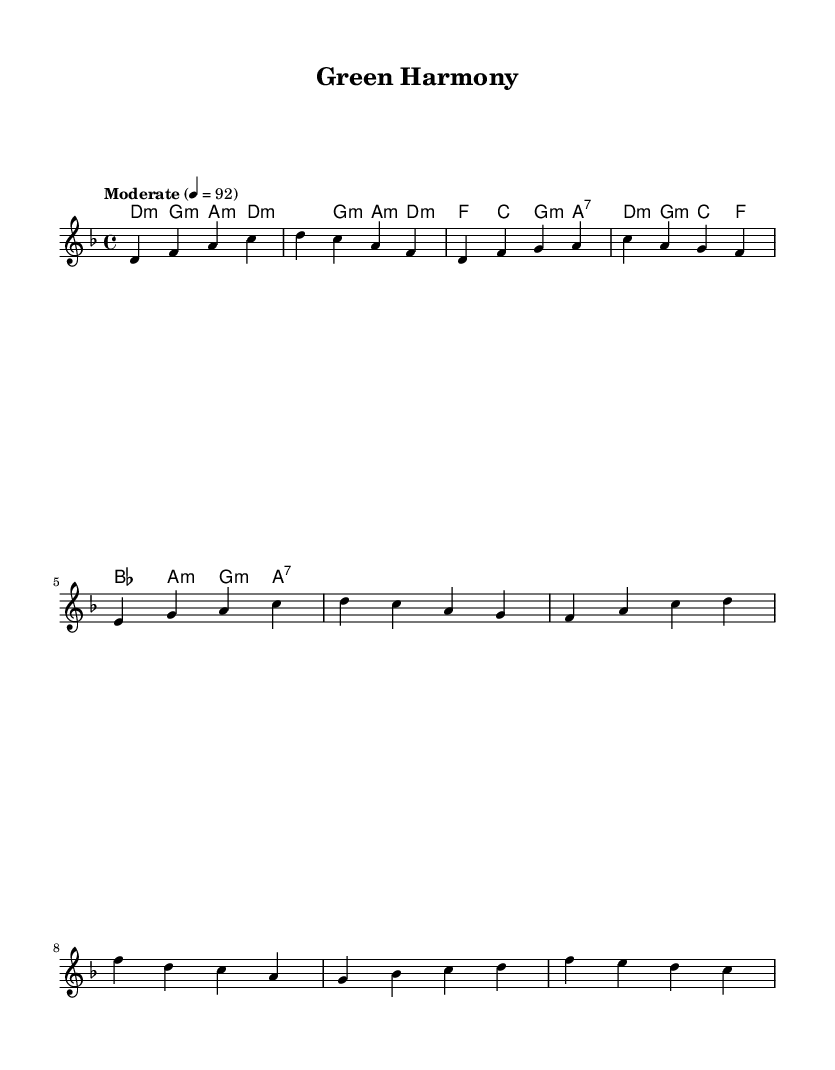What is the time signature of this music? The time signature is indicated on the left side of the staff and shows the fraction 4/4, which means there are four beats in each measure and the quarter note gets one beat.
Answer: 4/4 What key is this piece composed in? The key signature is specified at the beginning of the music with a "d minor" indication, which means the piece is set in the D minor scale.
Answer: D minor What is the tempo marking for this composition? The tempo marking is indicated in the header of the score with the word "Moderate" followed by a metronome marking of 92 beats per minute.
Answer: Moderate, 92 How many measures are present in the chorus section? By examining the notation for the chorus section, we can count the measures, which contains eight distinct phrases indicated by the vertical lines.
Answer: 8 Which chords appear in the verse section? The chords listed in the verse section from the chord mode indicate the specific chord changes as they appear, which are D minor, G minor, A minor, D minor, F, C, G minor, and A7.
Answer: D minor, G minor, A minor, F, C, A7 What is the first note of the melody? The first note of the melody is the note "D," which is located at the beginning of the melody line, signaling the starting pitch for the entire piece.
Answer: D What type of musical composition is this? The combination of jazz elements with global influences and themes of environmental conservation describes the genre mash-up, thus categorizing it as a fusion of jazz-infused world music.
Answer: Fusion 